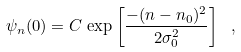Convert formula to latex. <formula><loc_0><loc_0><loc_500><loc_500>\psi _ { n } ( 0 ) = C \, \exp \left [ \frac { - ( n - n _ { 0 } ) ^ { 2 } } { 2 \sigma _ { 0 } ^ { 2 } } \right ] \ ,</formula> 